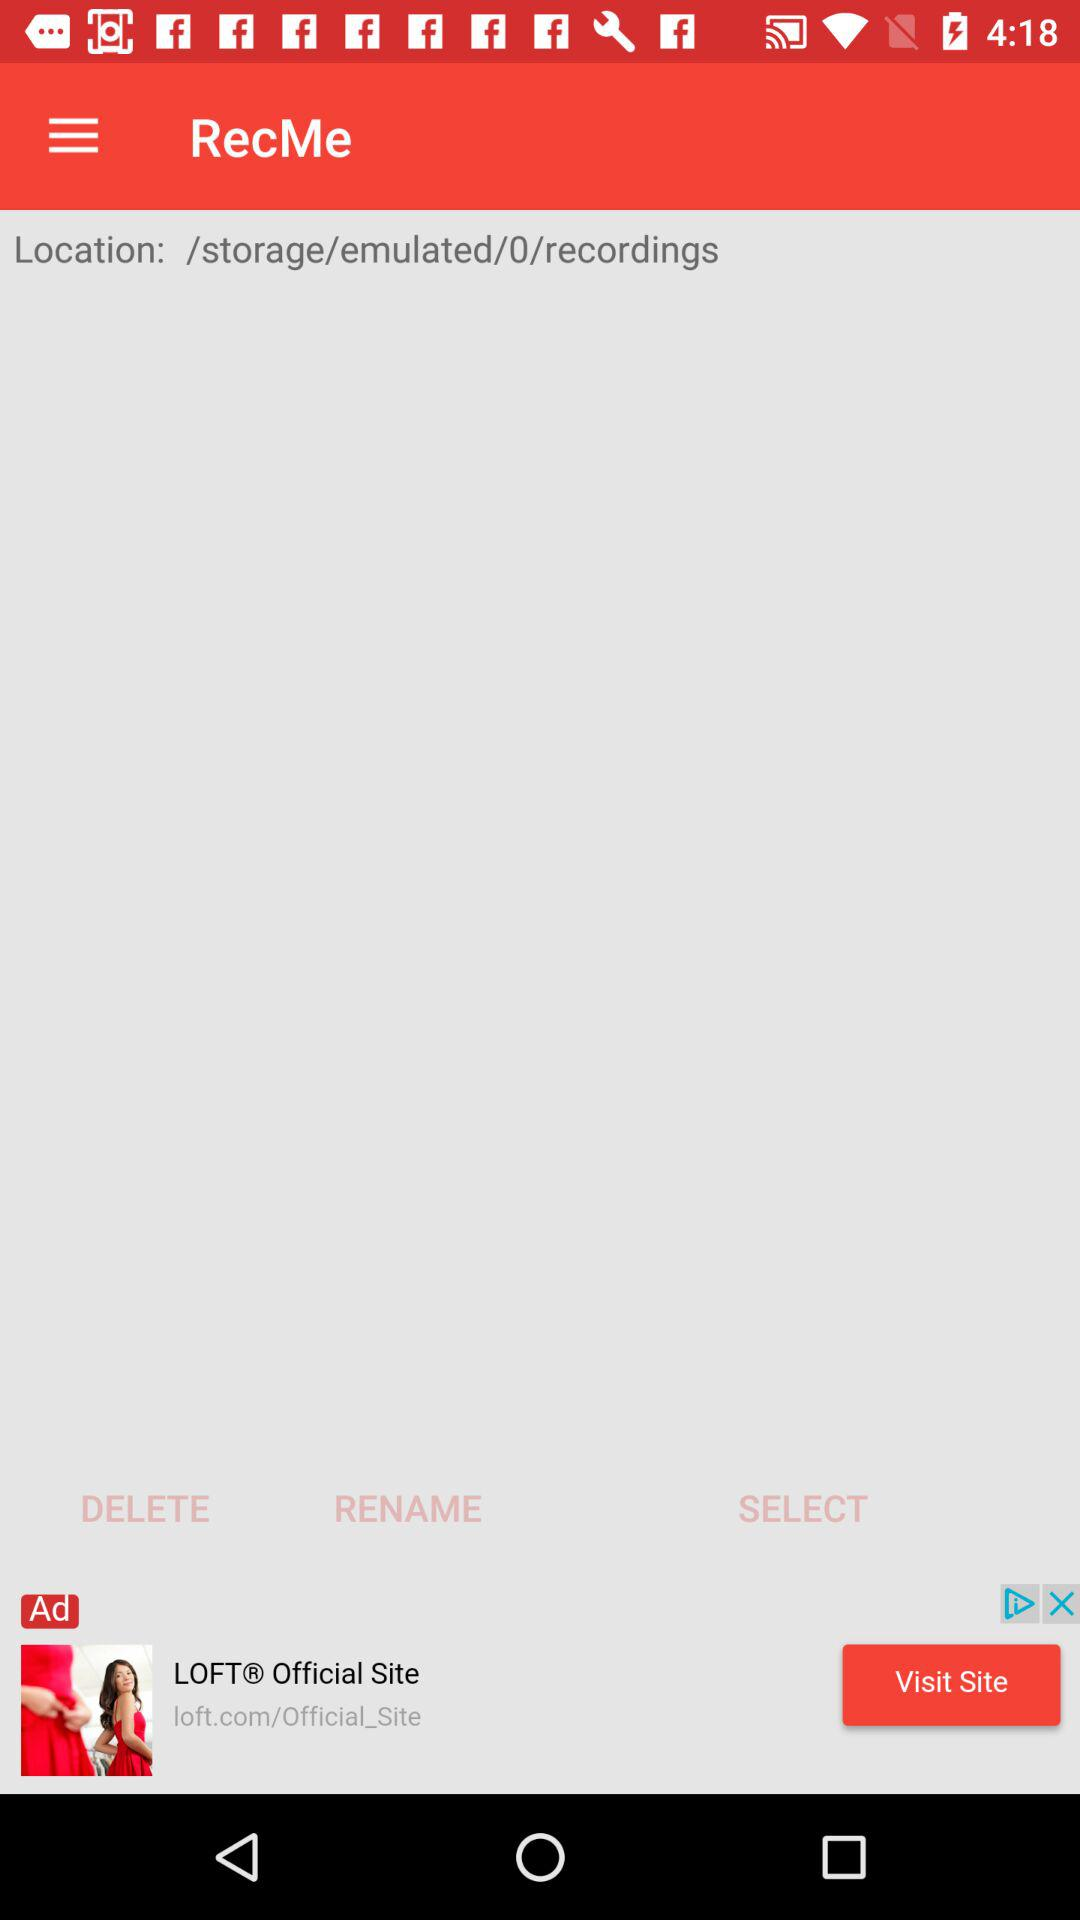What's the location? The location is /storage/emulated/0/recordings. 